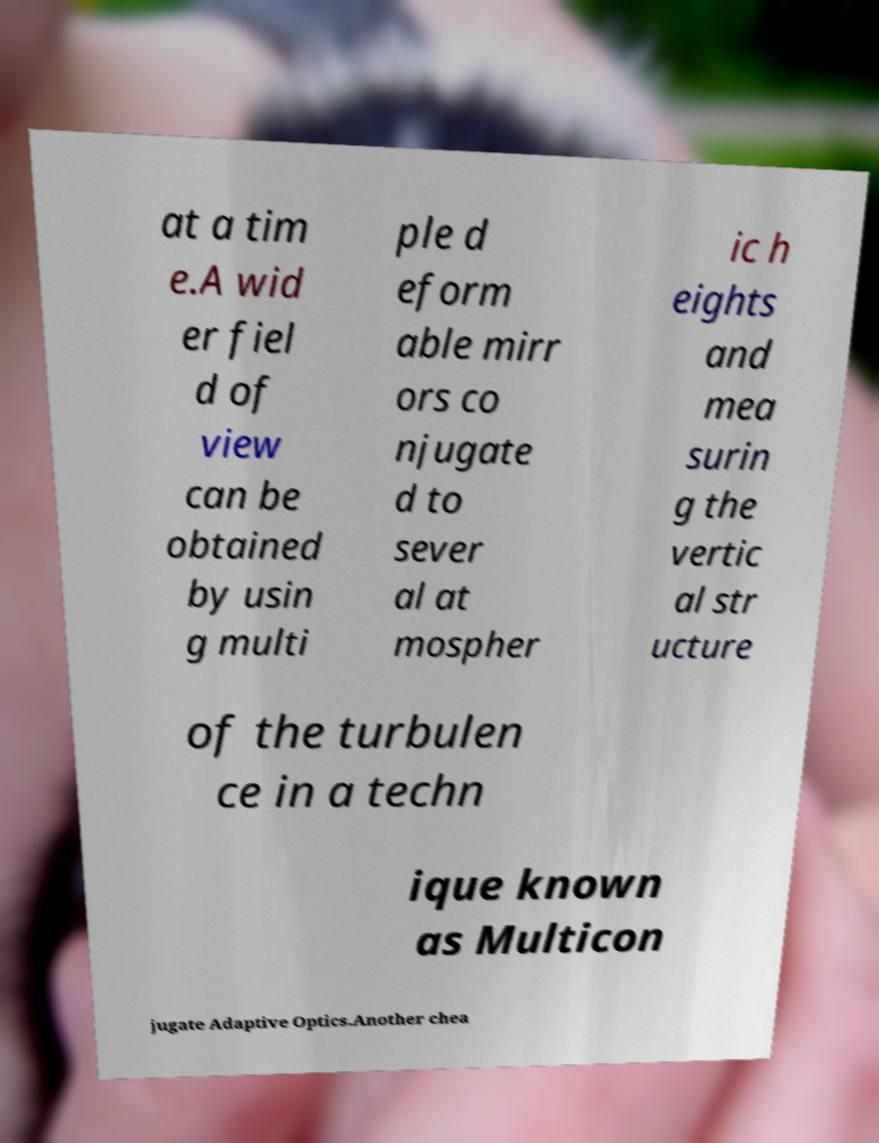Please read and relay the text visible in this image. What does it say? at a tim e.A wid er fiel d of view can be obtained by usin g multi ple d eform able mirr ors co njugate d to sever al at mospher ic h eights and mea surin g the vertic al str ucture of the turbulen ce in a techn ique known as Multicon jugate Adaptive Optics.Another chea 